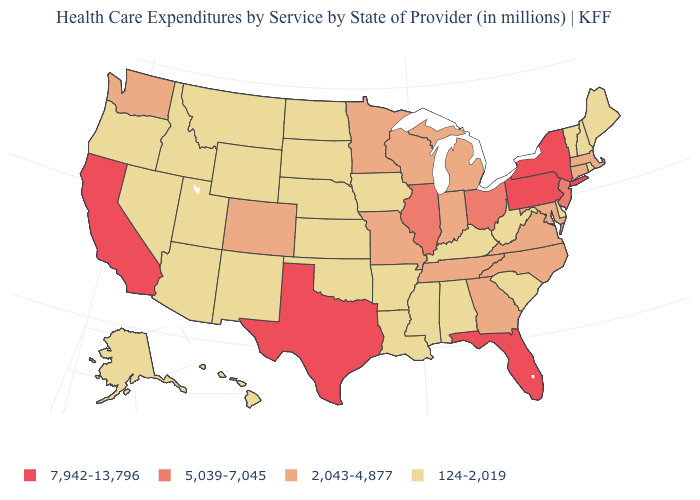Which states hav the highest value in the MidWest?
Write a very short answer. Illinois, Ohio. Name the states that have a value in the range 2,043-4,877?
Answer briefly. Colorado, Connecticut, Georgia, Indiana, Maryland, Massachusetts, Michigan, Minnesota, Missouri, North Carolina, Tennessee, Virginia, Washington, Wisconsin. Among the states that border Nevada , which have the lowest value?
Be succinct. Arizona, Idaho, Oregon, Utah. How many symbols are there in the legend?
Quick response, please. 4. Which states hav the highest value in the MidWest?
Be succinct. Illinois, Ohio. What is the highest value in states that border Texas?
Quick response, please. 124-2,019. Name the states that have a value in the range 2,043-4,877?
Be succinct. Colorado, Connecticut, Georgia, Indiana, Maryland, Massachusetts, Michigan, Minnesota, Missouri, North Carolina, Tennessee, Virginia, Washington, Wisconsin. Name the states that have a value in the range 7,942-13,796?
Quick response, please. California, Florida, New York, Pennsylvania, Texas. Does the map have missing data?
Concise answer only. No. Name the states that have a value in the range 5,039-7,045?
Write a very short answer. Illinois, New Jersey, Ohio. What is the value of Washington?
Keep it brief. 2,043-4,877. What is the highest value in states that border Minnesota?
Quick response, please. 2,043-4,877. Does Missouri have the same value as Alaska?
Be succinct. No. Name the states that have a value in the range 2,043-4,877?
Short answer required. Colorado, Connecticut, Georgia, Indiana, Maryland, Massachusetts, Michigan, Minnesota, Missouri, North Carolina, Tennessee, Virginia, Washington, Wisconsin. Which states have the highest value in the USA?
Short answer required. California, Florida, New York, Pennsylvania, Texas. 